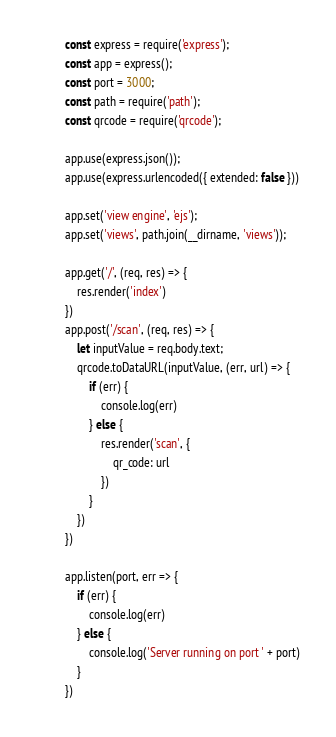Convert code to text. <code><loc_0><loc_0><loc_500><loc_500><_JavaScript_>const express = require('express');
const app = express();
const port = 3000;
const path = require('path');
const qrcode = require('qrcode');

app.use(express.json());
app.use(express.urlencoded({ extended: false }))

app.set('view engine', 'ejs');
app.set('views', path.join(__dirname, 'views'));

app.get('/', (req, res) => {
    res.render('index')
})
app.post('/scan', (req, res) => {
    let inputValue = req.body.text;
    qrcode.toDataURL(inputValue, (err, url) => {
        if (err) {
            console.log(err)
        } else {
            res.render('scan', {
                qr_code: url
            })
        }
    })
})

app.listen(port, err => {
    if (err) {
        console.log(err)
    } else {
        console.log('Server running on port ' + port)
    }
})</code> 